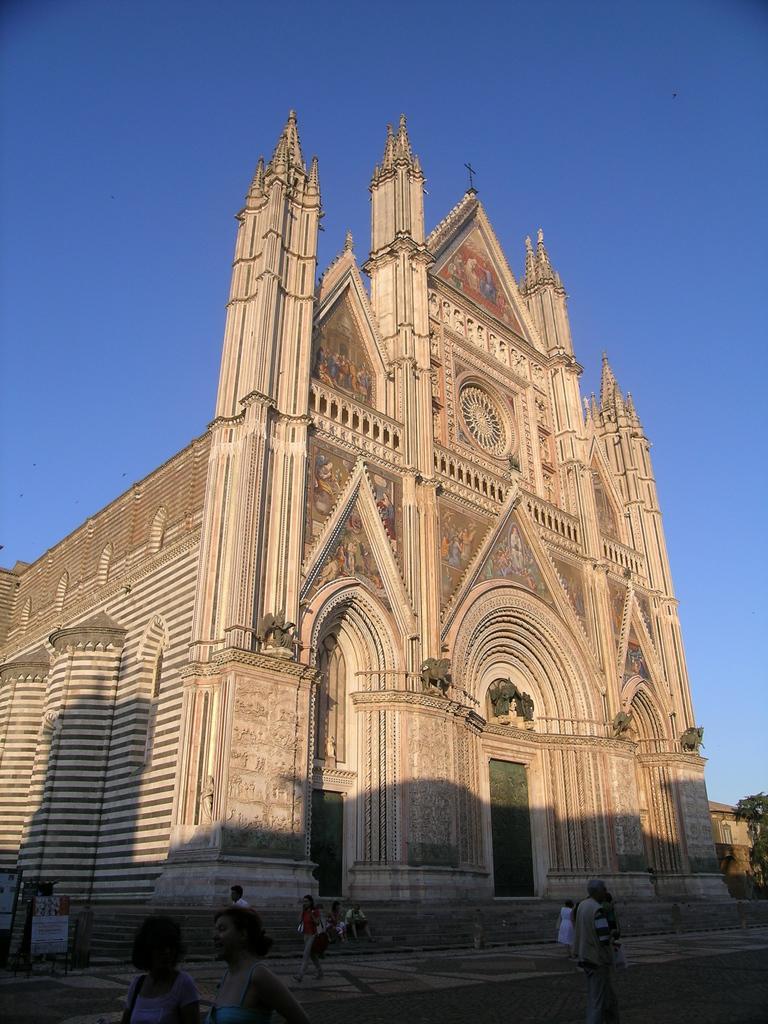Please provide a concise description of this image. In this image in front there are people walking on the road. Behind them there are buildings. There is a tree. On the left side of the image there are boards. In the background of the image there is sky. 